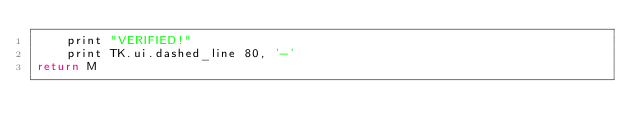<code> <loc_0><loc_0><loc_500><loc_500><_MoonScript_>    print "VERIFIED!"
    print TK.ui.dashed_line 80, '-'
return M</code> 